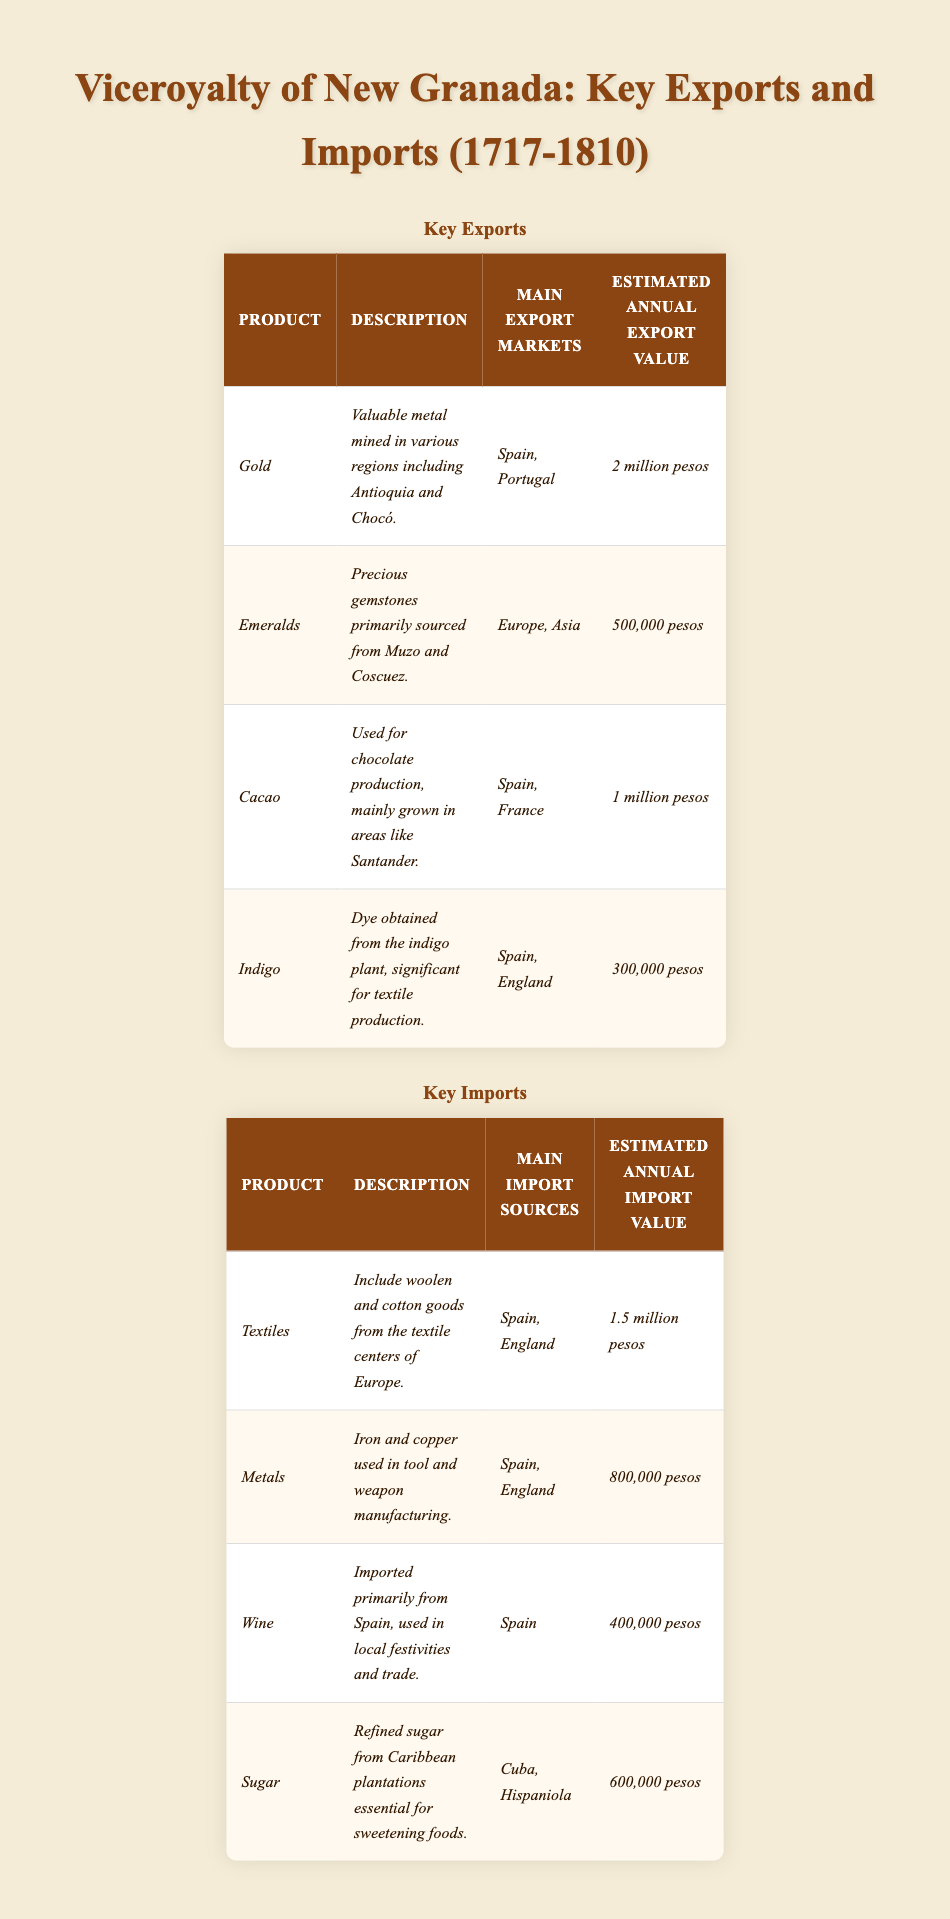What are the main export markets for Gold? Referring to the table under the Key Exports section, Gold's main export markets are listed as Spain and Portugal.
Answer: Spain, Portugal What is the estimated annual export value of Indigo? The table indicates that the estimated annual export value of Indigo is 300,000 pesos.
Answer: 300,000 pesos How much more is spent on importing Textiles compared to importing Wine? The estimated annual import value for Textiles is 1.5 million pesos and for Wine is 400,000 pesos. The difference is 1.5 million - 400,000 = 1.1 million pesos.
Answer: 1.1 million pesos Is Cacao imported or exported? According to the table, Cacao is listed under Key Exports, indicating that it is exported and not imported.
Answer: Exported What is the total estimated annual export value of all key exports? To find the total, add the estimated values: Gold (2 million) + Emeralds (500,000) + Cacao (1 million) + Indigo (300,000). This equals 3.8 million pesos.
Answer: 3.8 million pesos Which product has the highest estimated annual import value? By reviewing the Key Imports section, Textiles has the highest estimated annual import value at 1.5 million pesos, compared to other listed products.
Answer: Textiles What is the average estimated annual export value of the four main exports? To calculate the average, first sum the export values: 2 million + 500,000 + 1 million + 300,000 = 3.8 million. Next, divide by the number of products (4): 3.8 million / 4 = 950,000 pesos.
Answer: 950,000 pesos Are Emeralds primarily exported to Asia? The table specifies that Emeralds are primarily exported to Europe and Asia, making this statement true.
Answer: Yes How much less is the estimated annual import value of Sugar compared to Textiles? The estimated annual import values are: Textiles (1.5 million) and Sugar (600,000). The difference is 1.5 million - 600,000 = 900,000 pesos.
Answer: 900,000 pesos Which two products are the main import sources from Spain? According to the table, both Textiles and Metals have Spain as one of their main import sources.
Answer: Textiles, Metals 